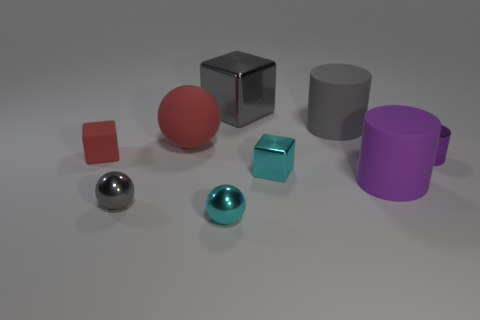How many objects are there in total, and can you describe their colors? There are seven objects in total, each with a unique color. Clockwise from the top left, there's a matte red cube, a glossy red sphere, a reflective silver sphere, a matte turquoise cube, a glossy purple cylinder, a matte gray cylinder, and a small, shiny copper-colored cube. 